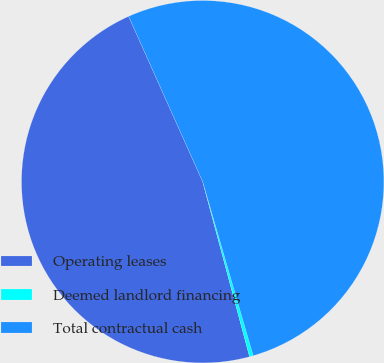Convert chart. <chart><loc_0><loc_0><loc_500><loc_500><pie_chart><fcel>Operating leases<fcel>Deemed landlord financing<fcel>Total contractual cash<nl><fcel>47.46%<fcel>0.33%<fcel>52.21%<nl></chart> 